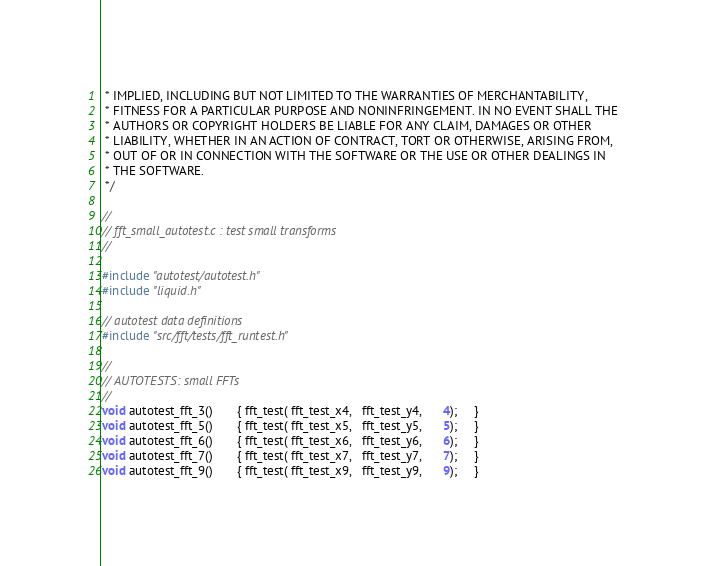<code> <loc_0><loc_0><loc_500><loc_500><_C_> * IMPLIED, INCLUDING BUT NOT LIMITED TO THE WARRANTIES OF MERCHANTABILITY,
 * FITNESS FOR A PARTICULAR PURPOSE AND NONINFRINGEMENT. IN NO EVENT SHALL THE
 * AUTHORS OR COPYRIGHT HOLDERS BE LIABLE FOR ANY CLAIM, DAMAGES OR OTHER
 * LIABILITY, WHETHER IN AN ACTION OF CONTRACT, TORT OR OTHERWISE, ARISING FROM,
 * OUT OF OR IN CONNECTION WITH THE SOFTWARE OR THE USE OR OTHER DEALINGS IN
 * THE SOFTWARE.
 */

//
// fft_small_autotest.c : test small transforms
//

#include "autotest/autotest.h"
#include "liquid.h"

// autotest data definitions
#include "src/fft/tests/fft_runtest.h"

// 
// AUTOTESTS: small FFTs
//
void autotest_fft_3()       { fft_test( fft_test_x4,   fft_test_y4,      4);     }
void autotest_fft_5()       { fft_test( fft_test_x5,   fft_test_y5,      5);     }
void autotest_fft_6()       { fft_test( fft_test_x6,   fft_test_y6,      6);     }
void autotest_fft_7()       { fft_test( fft_test_x7,   fft_test_y7,      7);     }
void autotest_fft_9()       { fft_test( fft_test_x9,   fft_test_y9,      9);     }

</code> 